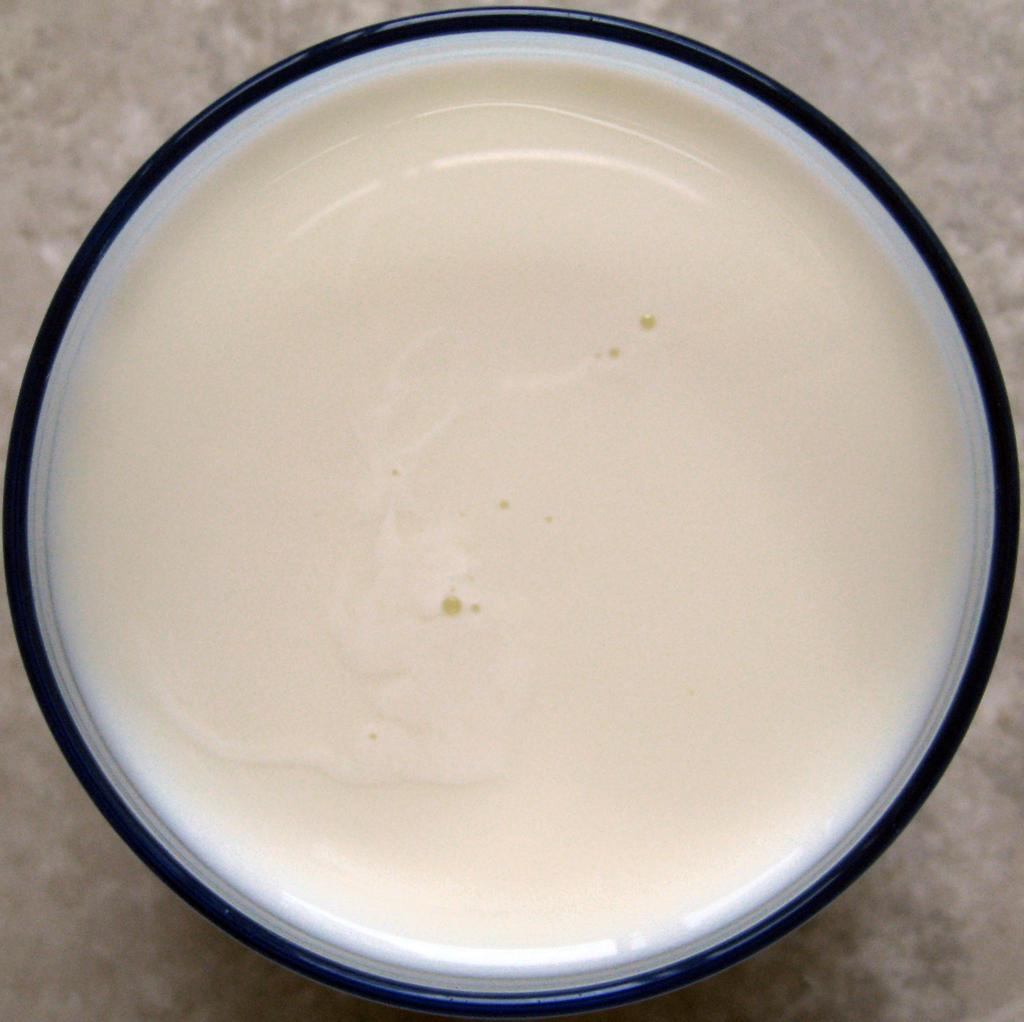What is contained in the bowl in the image? There is a bowl with liquid in the image. What can be seen below the bowl in the image? There is a floor visible at the bottom of the image. What type of crime is being committed in the image? There is no crime or criminal activity depicted in the image. What is the mind doing in the image? The mind is not a physical object and cannot be seen or depicted in the image. 